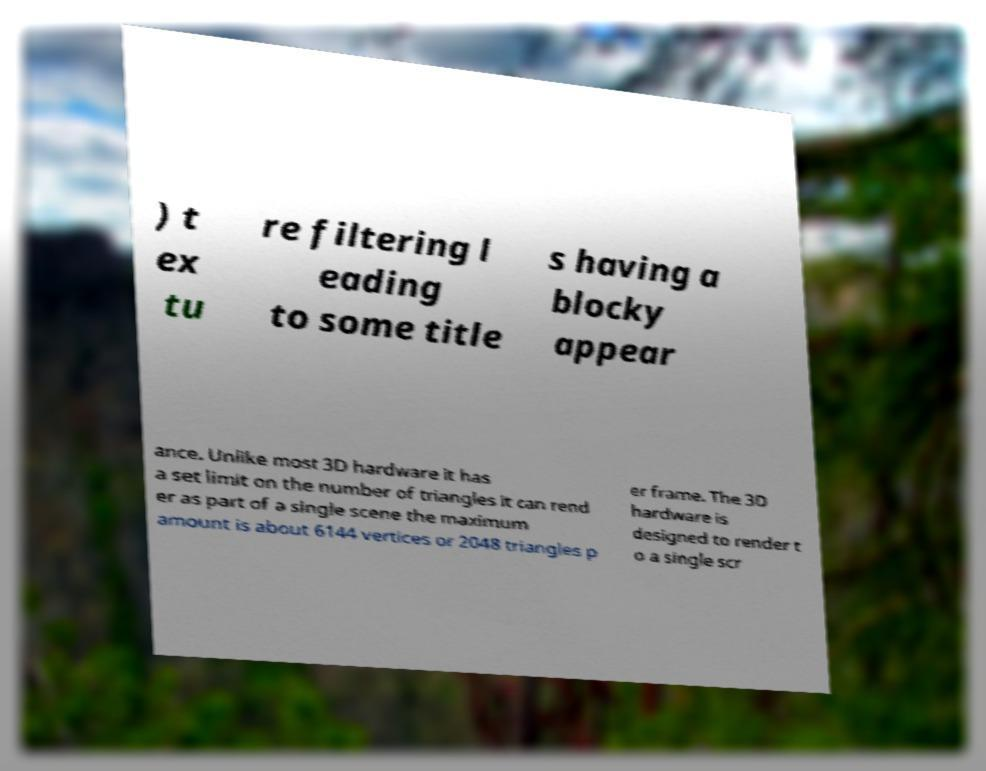Could you assist in decoding the text presented in this image and type it out clearly? ) t ex tu re filtering l eading to some title s having a blocky appear ance. Unlike most 3D hardware it has a set limit on the number of triangles it can rend er as part of a single scene the maximum amount is about 6144 vertices or 2048 triangles p er frame. The 3D hardware is designed to render t o a single scr 